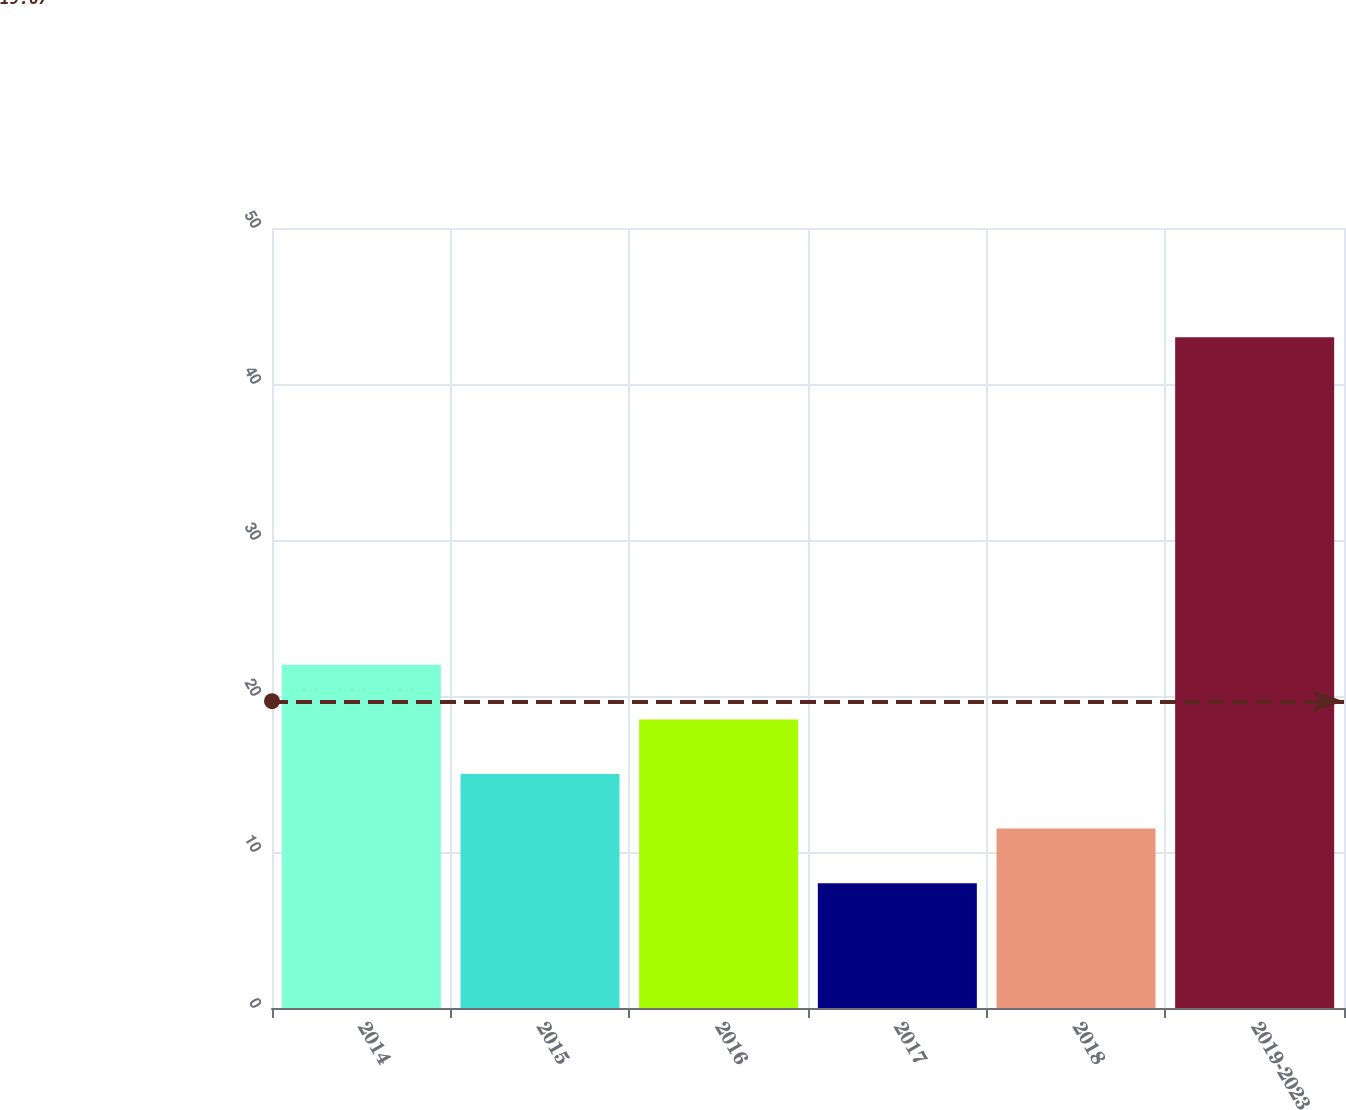<chart> <loc_0><loc_0><loc_500><loc_500><bar_chart><fcel>2014<fcel>2015<fcel>2016<fcel>2017<fcel>2018<fcel>2019-2023<nl><fcel>22<fcel>15<fcel>18.5<fcel>8<fcel>11.5<fcel>43<nl></chart> 